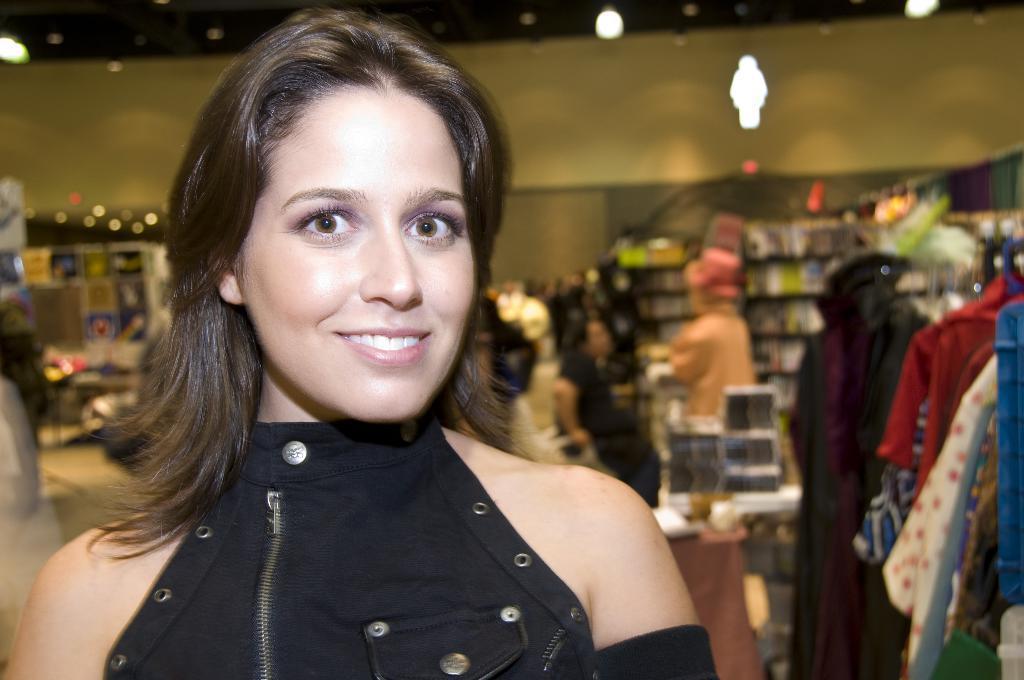Can you describe this image briefly? In this picture I can see a woman smiling, and in the background there are group of people , lights, clothes and some other items. 